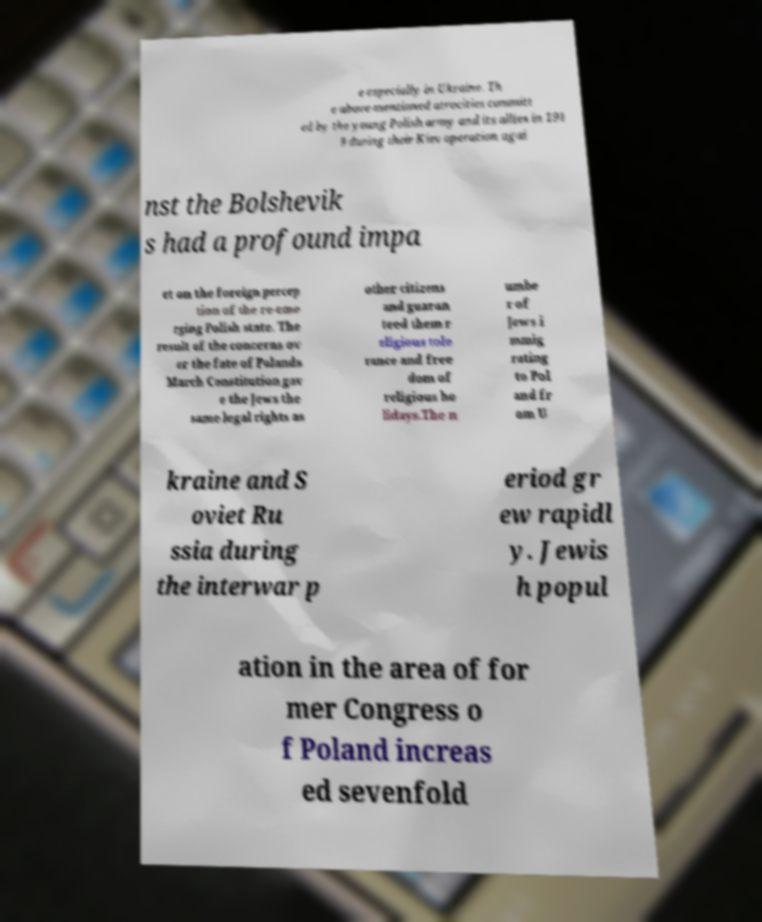Can you accurately transcribe the text from the provided image for me? e especially in Ukraine. Th e above-mentioned atrocities committ ed by the young Polish army and its allies in 191 9 during their Kiev operation agai nst the Bolshevik s had a profound impa ct on the foreign percep tion of the re-eme rging Polish state. The result of the concerns ov er the fate of Polands March Constitution gav e the Jews the same legal rights as other citizens and guaran teed them r eligious tole rance and free dom of religious ho lidays.The n umbe r of Jews i mmig rating to Pol and fr om U kraine and S oviet Ru ssia during the interwar p eriod gr ew rapidl y. Jewis h popul ation in the area of for mer Congress o f Poland increas ed sevenfold 